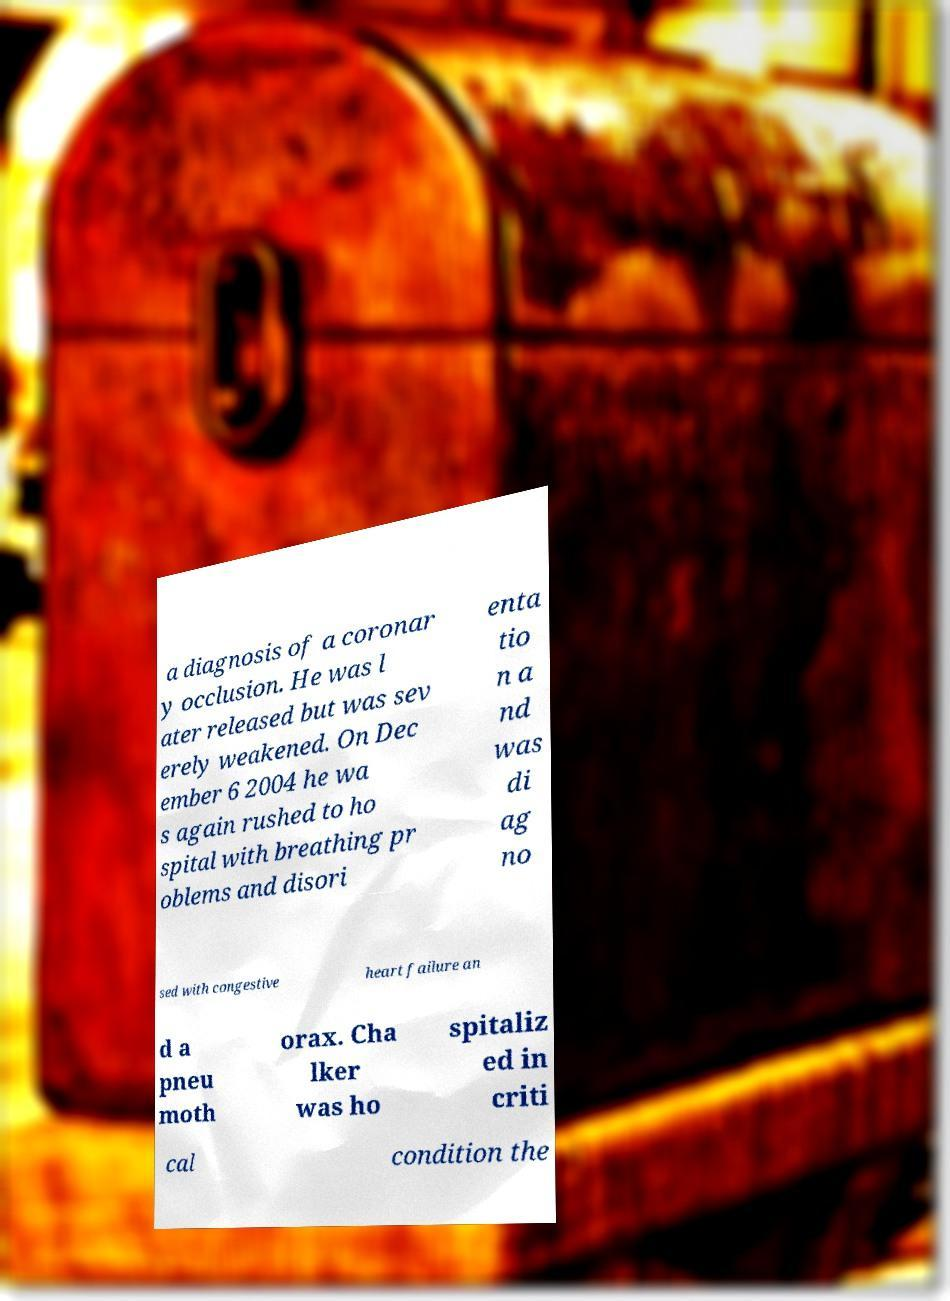There's text embedded in this image that I need extracted. Can you transcribe it verbatim? a diagnosis of a coronar y occlusion. He was l ater released but was sev erely weakened. On Dec ember 6 2004 he wa s again rushed to ho spital with breathing pr oblems and disori enta tio n a nd was di ag no sed with congestive heart failure an d a pneu moth orax. Cha lker was ho spitaliz ed in criti cal condition the 